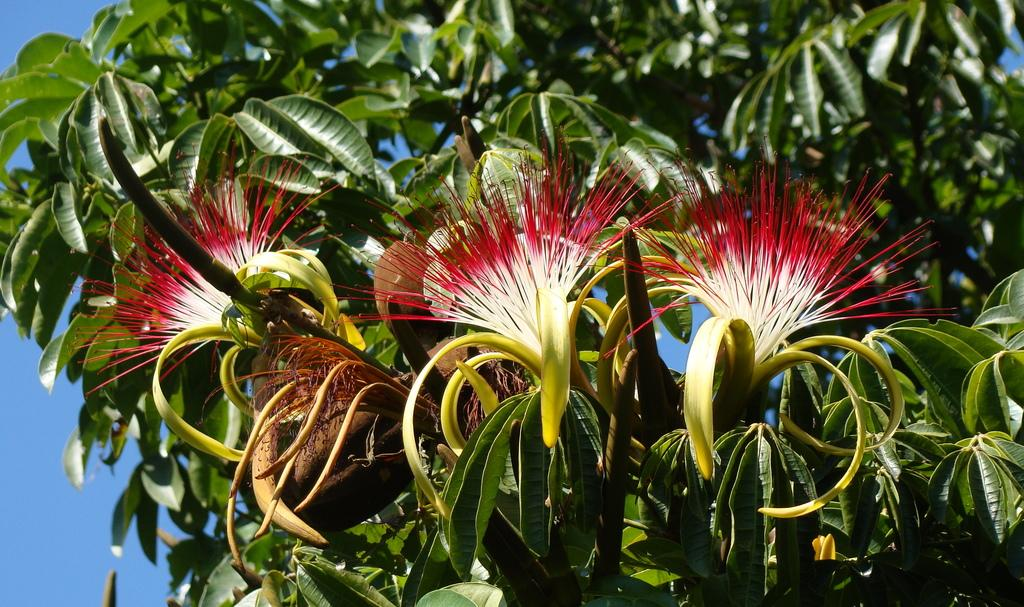What type of living organisms can be seen in the image? There are flowers in the image. Where are the flowers located? The flowers are on a plant. What colors are the flowers? The flowers are in red and white colors. What color is the background of the image? The background of the image is blue. How does the plant suggest a change in the weather? The image does not provide any information about the plant suggesting a change in the weather, nor does it depict any weather-related elements. 